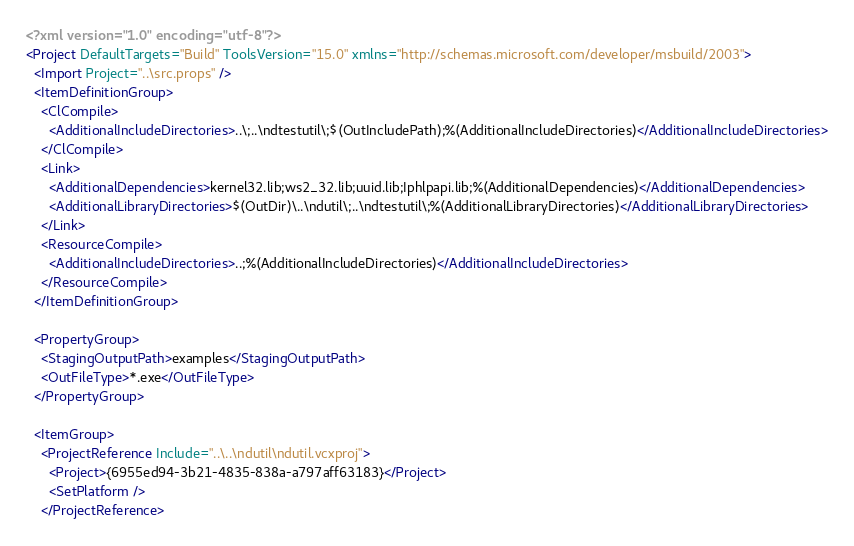Convert code to text. <code><loc_0><loc_0><loc_500><loc_500><_XML_><?xml version="1.0" encoding="utf-8"?>
<Project DefaultTargets="Build" ToolsVersion="15.0" xmlns="http://schemas.microsoft.com/developer/msbuild/2003">
  <Import Project="..\src.props" />
  <ItemDefinitionGroup>
    <ClCompile>
      <AdditionalIncludeDirectories>..\;..\ndtestutil\;$(OutIncludePath);%(AdditionalIncludeDirectories)</AdditionalIncludeDirectories>
    </ClCompile>
    <Link>
      <AdditionalDependencies>kernel32.lib;ws2_32.lib;uuid.lib;Iphlpapi.lib;%(AdditionalDependencies)</AdditionalDependencies>
      <AdditionalLibraryDirectories>$(OutDir)\..\ndutil\;..\ndtestutil\;%(AdditionalLibraryDirectories)</AdditionalLibraryDirectories>
    </Link>
    <ResourceCompile>
      <AdditionalIncludeDirectories>..;%(AdditionalIncludeDirectories)</AdditionalIncludeDirectories>
    </ResourceCompile>
  </ItemDefinitionGroup>

  <PropertyGroup>
    <StagingOutputPath>examples</StagingOutputPath>
    <OutFileType>*.exe</OutFileType>
  </PropertyGroup>

  <ItemGroup>
    <ProjectReference Include="..\..\ndutil\ndutil.vcxproj">
      <Project>{6955ed94-3b21-4835-838a-a797aff63183}</Project>
      <SetPlatform />
    </ProjectReference></code> 